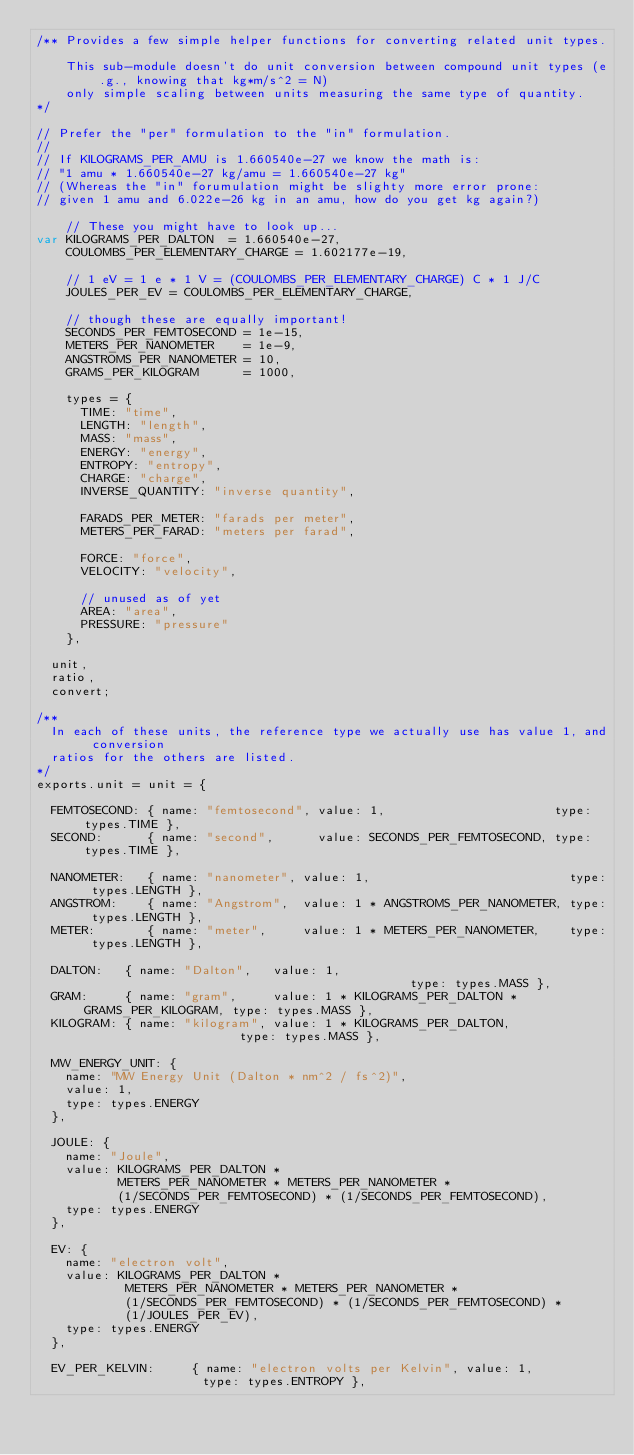Convert code to text. <code><loc_0><loc_0><loc_500><loc_500><_JavaScript_>/** Provides a few simple helper functions for converting related unit types.

    This sub-module doesn't do unit conversion between compound unit types (e.g., knowing that kg*m/s^2 = N)
    only simple scaling between units measuring the same type of quantity.
*/

// Prefer the "per" formulation to the "in" formulation.
//
// If KILOGRAMS_PER_AMU is 1.660540e-27 we know the math is:
// "1 amu * 1.660540e-27 kg/amu = 1.660540e-27 kg"
// (Whereas the "in" forumulation might be slighty more error prone:
// given 1 amu and 6.022e-26 kg in an amu, how do you get kg again?)

    // These you might have to look up...
var KILOGRAMS_PER_DALTON  = 1.660540e-27,
    COULOMBS_PER_ELEMENTARY_CHARGE = 1.602177e-19,

    // 1 eV = 1 e * 1 V = (COULOMBS_PER_ELEMENTARY_CHARGE) C * 1 J/C
    JOULES_PER_EV = COULOMBS_PER_ELEMENTARY_CHARGE,

    // though these are equally important!
    SECONDS_PER_FEMTOSECOND = 1e-15,
    METERS_PER_NANOMETER    = 1e-9,
    ANGSTROMS_PER_NANOMETER = 10,
    GRAMS_PER_KILOGRAM      = 1000,

    types = {
      TIME: "time",
      LENGTH: "length",
      MASS: "mass",
      ENERGY: "energy",
      ENTROPY: "entropy",
      CHARGE: "charge",
      INVERSE_QUANTITY: "inverse quantity",

      FARADS_PER_METER: "farads per meter",
      METERS_PER_FARAD: "meters per farad",

      FORCE: "force",
      VELOCITY: "velocity",

      // unused as of yet
      AREA: "area",
      PRESSURE: "pressure"
    },

  unit,
  ratio,
  convert;

/**
  In each of these units, the reference type we actually use has value 1, and conversion
  ratios for the others are listed.
*/
exports.unit = unit = {

  FEMTOSECOND: { name: "femtosecond", value: 1,                       type: types.TIME },
  SECOND:      { name: "second",      value: SECONDS_PER_FEMTOSECOND, type: types.TIME },

  NANOMETER:   { name: "nanometer", value: 1,                           type: types.LENGTH },
  ANGSTROM:    { name: "Angstrom",  value: 1 * ANGSTROMS_PER_NANOMETER, type: types.LENGTH },
  METER:       { name: "meter",     value: 1 * METERS_PER_NANOMETER,    type: types.LENGTH },

  DALTON:   { name: "Dalton",   value: 1,                                             type: types.MASS },
  GRAM:     { name: "gram",     value: 1 * KILOGRAMS_PER_DALTON * GRAMS_PER_KILOGRAM, type: types.MASS },
  KILOGRAM: { name: "kilogram", value: 1 * KILOGRAMS_PER_DALTON,                      type: types.MASS },

  MW_ENERGY_UNIT: {
    name: "MW Energy Unit (Dalton * nm^2 / fs^2)",
    value: 1,
    type: types.ENERGY
  },

  JOULE: {
    name: "Joule",
    value: KILOGRAMS_PER_DALTON *
           METERS_PER_NANOMETER * METERS_PER_NANOMETER *
           (1/SECONDS_PER_FEMTOSECOND) * (1/SECONDS_PER_FEMTOSECOND),
    type: types.ENERGY
  },

  EV: {
    name: "electron volt",
    value: KILOGRAMS_PER_DALTON *
            METERS_PER_NANOMETER * METERS_PER_NANOMETER *
            (1/SECONDS_PER_FEMTOSECOND) * (1/SECONDS_PER_FEMTOSECOND) *
            (1/JOULES_PER_EV),
    type: types.ENERGY
  },

  EV_PER_KELVIN:     { name: "electron volts per Kelvin", value: 1,                 type: types.ENTROPY },</code> 